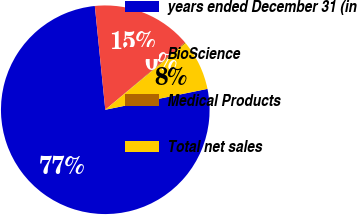Convert chart. <chart><loc_0><loc_0><loc_500><loc_500><pie_chart><fcel>years ended December 31 (in<fcel>BioScience<fcel>Medical Products<fcel>Total net sales<nl><fcel>76.61%<fcel>15.44%<fcel>0.15%<fcel>7.8%<nl></chart> 